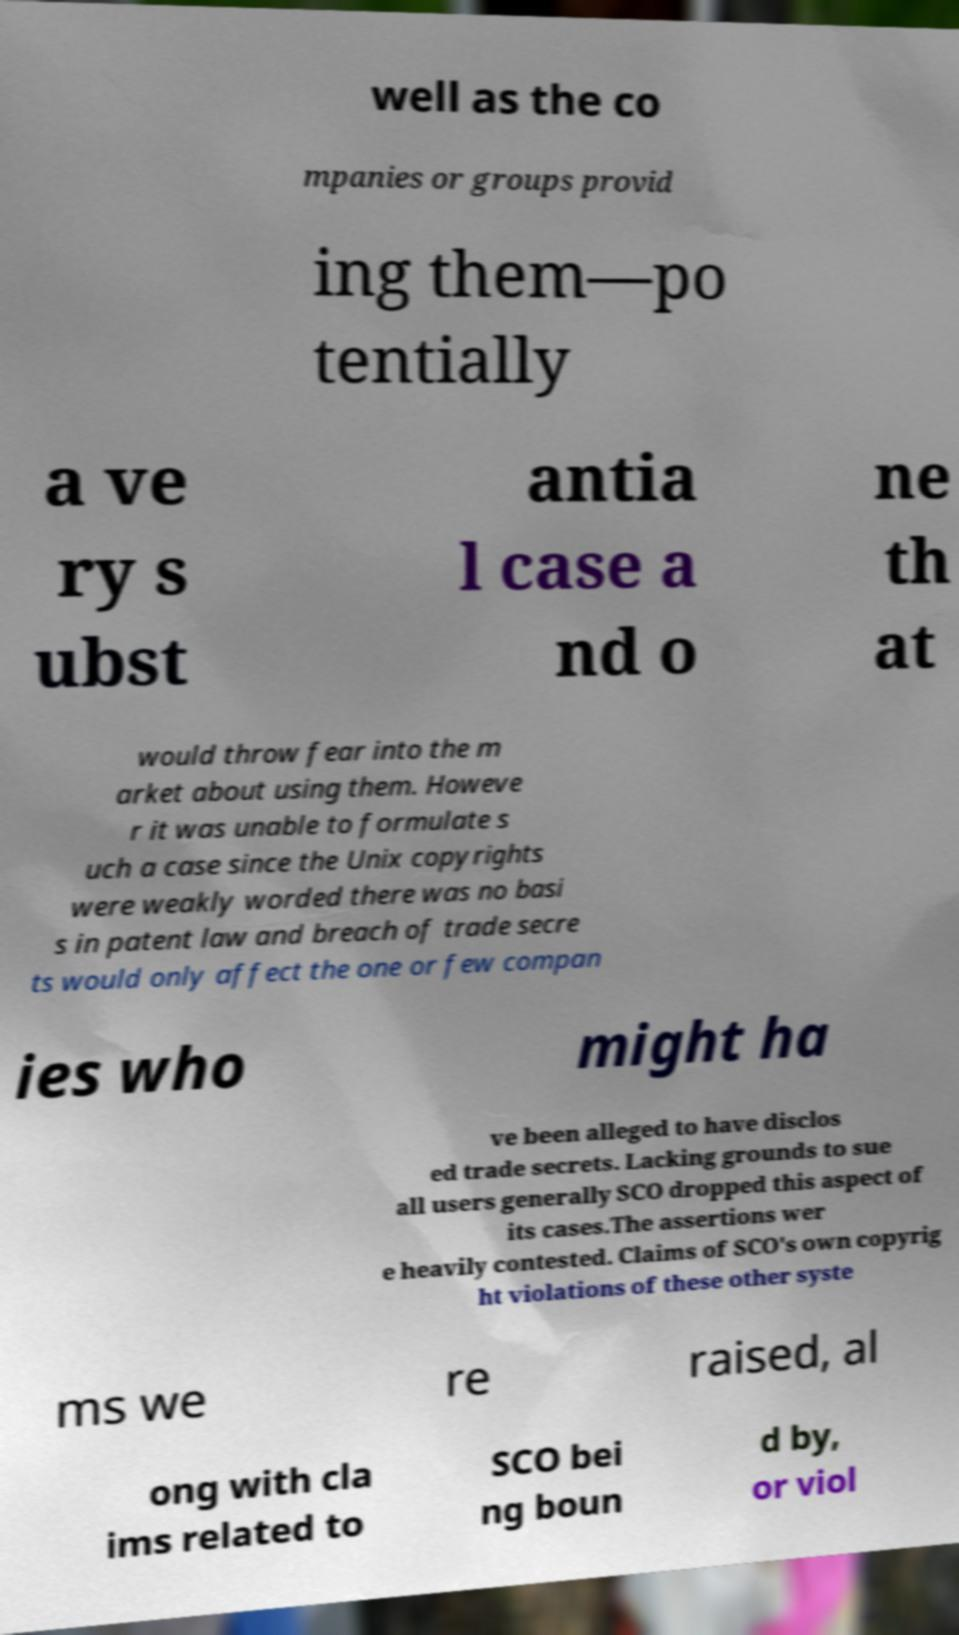Can you accurately transcribe the text from the provided image for me? well as the co mpanies or groups provid ing them—po tentially a ve ry s ubst antia l case a nd o ne th at would throw fear into the m arket about using them. Howeve r it was unable to formulate s uch a case since the Unix copyrights were weakly worded there was no basi s in patent law and breach of trade secre ts would only affect the one or few compan ies who might ha ve been alleged to have disclos ed trade secrets. Lacking grounds to sue all users generally SCO dropped this aspect of its cases.The assertions wer e heavily contested. Claims of SCO's own copyrig ht violations of these other syste ms we re raised, al ong with cla ims related to SCO bei ng boun d by, or viol 